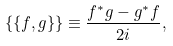<formula> <loc_0><loc_0><loc_500><loc_500>\{ \{ f , g \} \} \equiv \frac { f ^ { * } g - g ^ { * } f } { 2 i } ,</formula> 